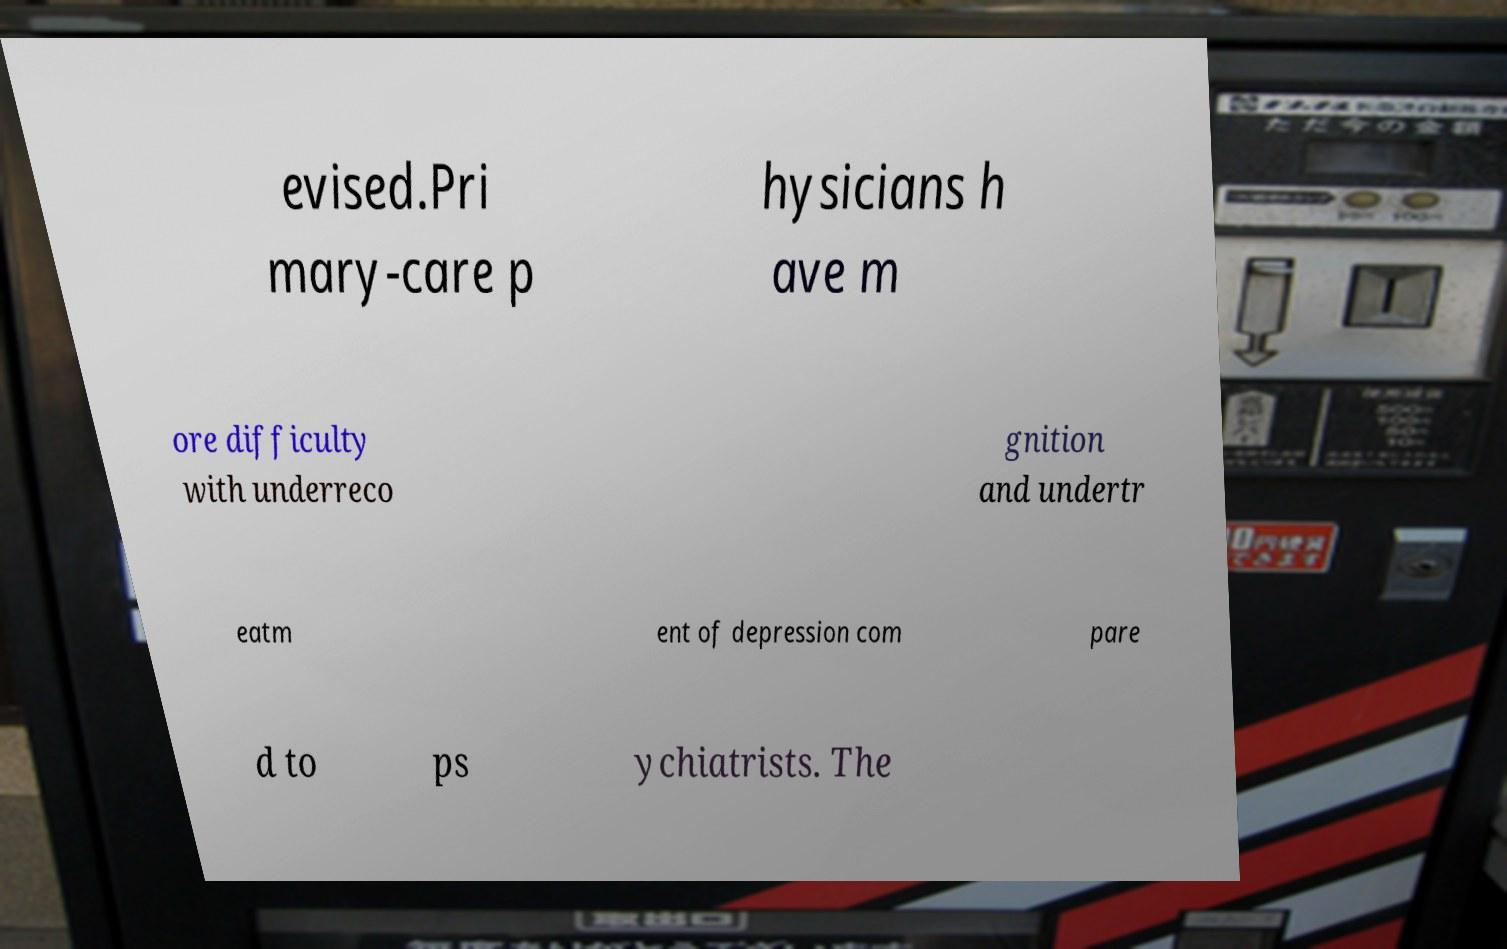There's text embedded in this image that I need extracted. Can you transcribe it verbatim? evised.Pri mary-care p hysicians h ave m ore difficulty with underreco gnition and undertr eatm ent of depression com pare d to ps ychiatrists. The 